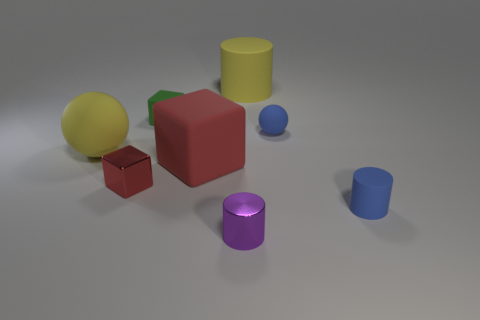Add 2 large yellow cylinders. How many objects exist? 10 Subtract all cylinders. How many objects are left? 5 Add 6 tiny blue matte balls. How many tiny blue matte balls exist? 7 Subtract 1 blue cylinders. How many objects are left? 7 Subtract all rubber blocks. Subtract all large green metallic cubes. How many objects are left? 6 Add 8 balls. How many balls are left? 10 